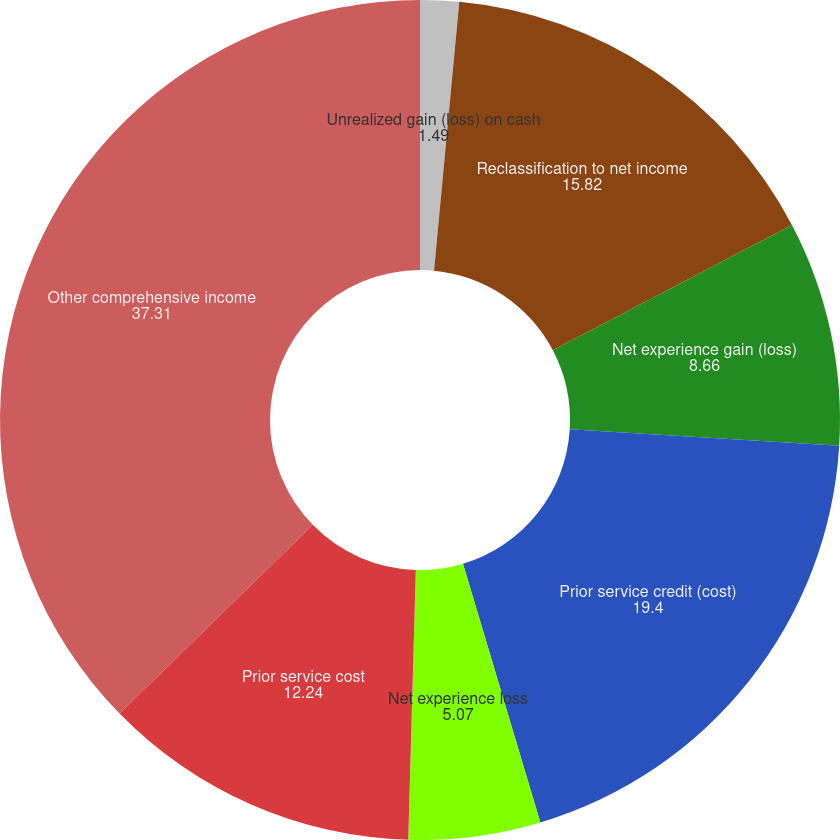Convert chart to OTSL. <chart><loc_0><loc_0><loc_500><loc_500><pie_chart><fcel>Unrealized gain (loss) on cash<fcel>Reclassification to net income<fcel>Net experience gain (loss)<fcel>Prior service credit (cost)<fcel>Net experience loss<fcel>Prior service cost<fcel>Other comprehensive income<nl><fcel>1.49%<fcel>15.82%<fcel>8.66%<fcel>19.4%<fcel>5.07%<fcel>12.24%<fcel>37.31%<nl></chart> 